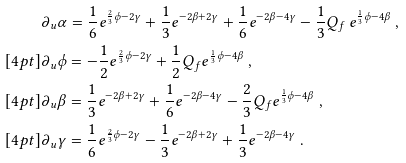<formula> <loc_0><loc_0><loc_500><loc_500>& \partial _ { u } \alpha = \frac { 1 } { 6 } e ^ { \frac { 2 } { 3 } \phi - 2 \gamma } + \frac { 1 } { 3 } e ^ { - 2 \beta + 2 \gamma } + \frac { 1 } { 6 } e ^ { - 2 \beta - 4 \gamma } - \frac { 1 } { 3 } Q _ { f } \, e ^ { \frac { 1 } { 3 } \phi - 4 \beta } \ , \\ [ 4 p t ] & \partial _ { u } \phi = - \frac { 1 } { 2 } e ^ { \frac { 2 } { 3 } \phi - 2 \gamma } + \frac { 1 } { 2 } Q _ { f } e ^ { \frac { 1 } { 3 } \phi - 4 \beta } \ , \\ [ 4 p t ] & \partial _ { u } \beta = \frac { 1 } { 3 } e ^ { - 2 \beta + 2 \gamma } + \frac { 1 } { 6 } e ^ { - 2 \beta - 4 \gamma } - \frac { 2 } { 3 } Q _ { f } e ^ { \frac { 1 } { 3 } \phi - 4 \beta } \ , \\ [ 4 p t ] & \partial _ { u } \gamma = \frac { 1 } { 6 } e ^ { \frac { 2 } { 3 } \phi - 2 \gamma } - \frac { 1 } { 3 } e ^ { - 2 \beta + 2 \gamma } + \frac { 1 } { 3 } e ^ { - 2 \beta - 4 \gamma } \ .</formula> 